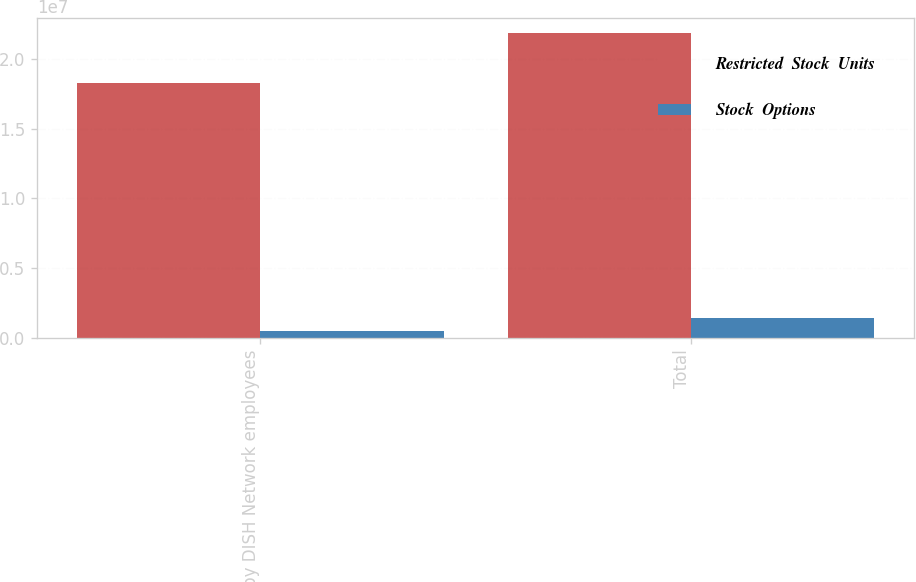Convert chart. <chart><loc_0><loc_0><loc_500><loc_500><stacked_bar_chart><ecel><fcel>Held by DISH Network employees<fcel>Total<nl><fcel>Restricted  Stock  Units<fcel>1.8268e+07<fcel>2.18357e+07<nl><fcel>Stock  Options<fcel>517735<fcel>1.45273e+06<nl></chart> 